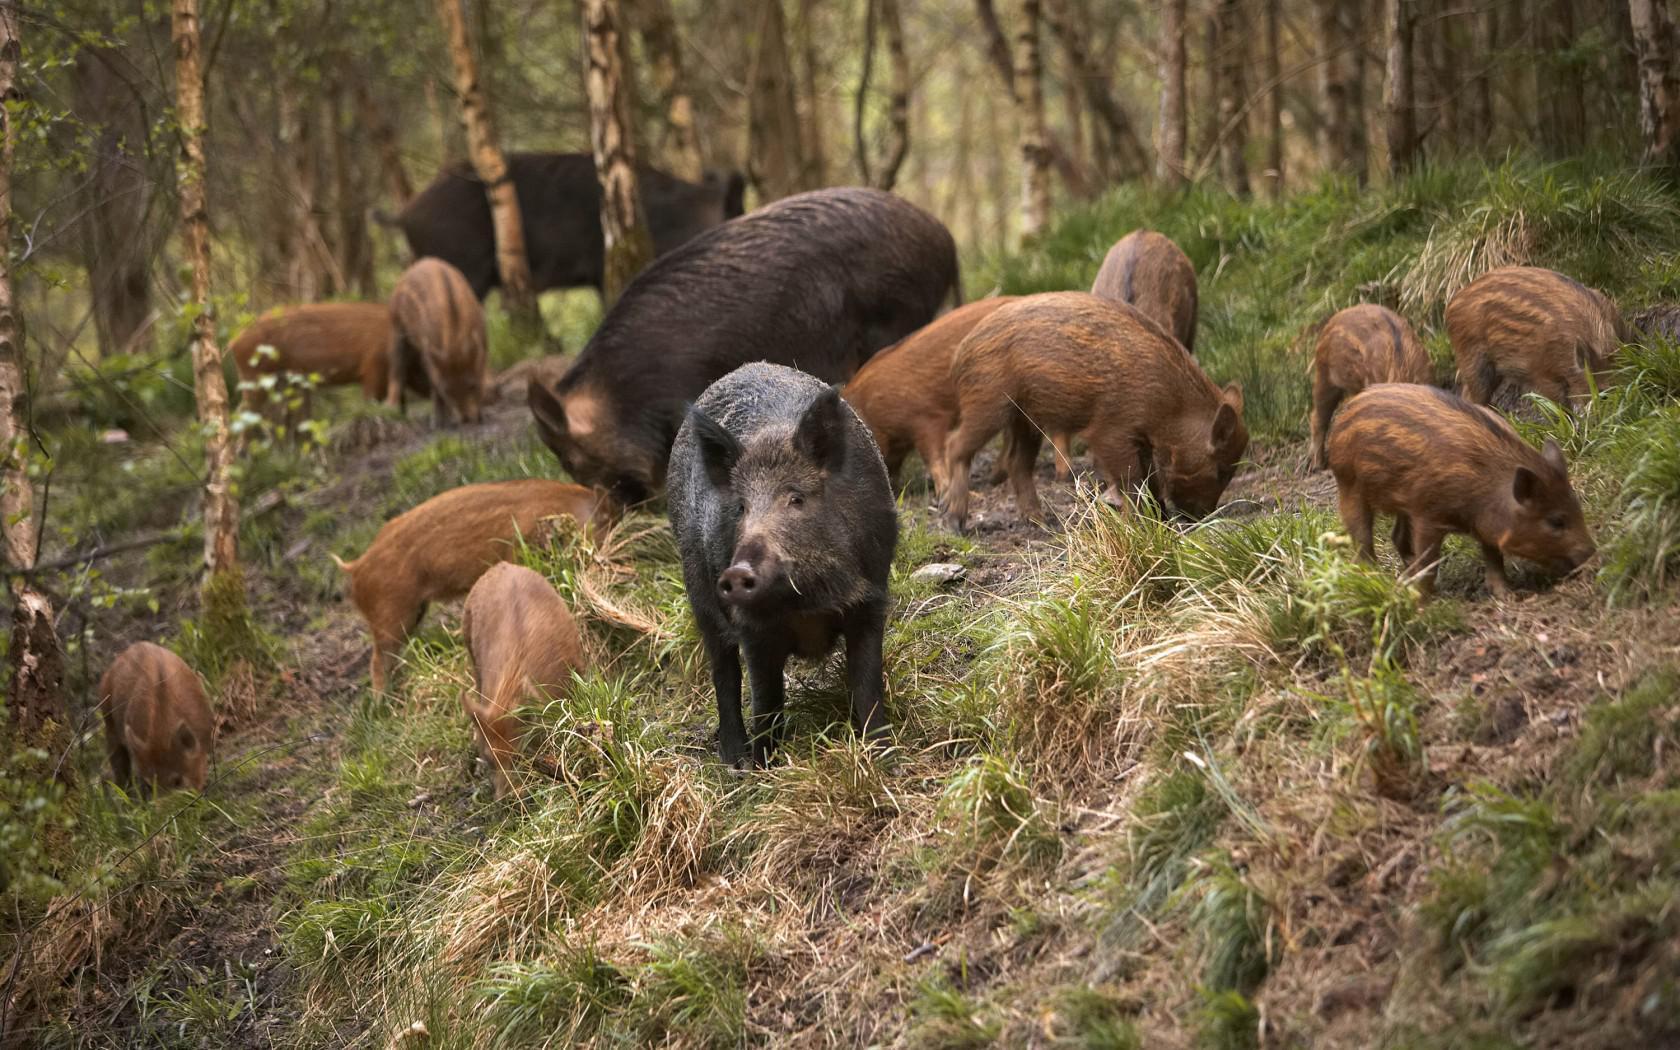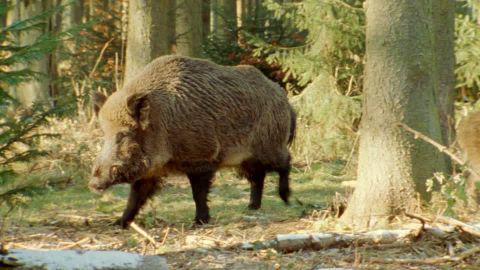The first image is the image on the left, the second image is the image on the right. Given the left and right images, does the statement "In the image on the right all of the warthogs are walking to the left." hold true? Answer yes or no. Yes. The first image is the image on the left, the second image is the image on the right. Evaluate the accuracy of this statement regarding the images: "the right image contains no more than five boars.". Is it true? Answer yes or no. Yes. 